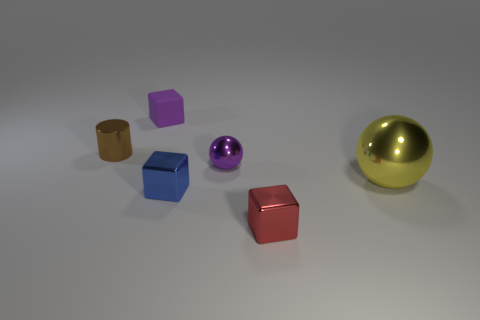Add 1 yellow metal balls. How many objects exist? 7 Subtract all cylinders. How many objects are left? 5 Subtract all large red metal things. Subtract all blue metal things. How many objects are left? 5 Add 3 yellow shiny objects. How many yellow shiny objects are left? 4 Add 5 purple balls. How many purple balls exist? 6 Subtract 0 gray balls. How many objects are left? 6 